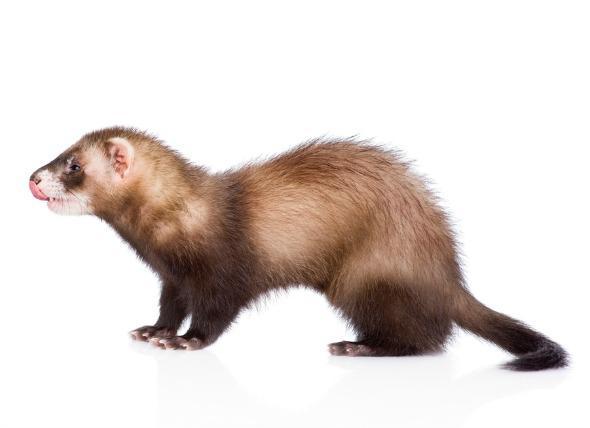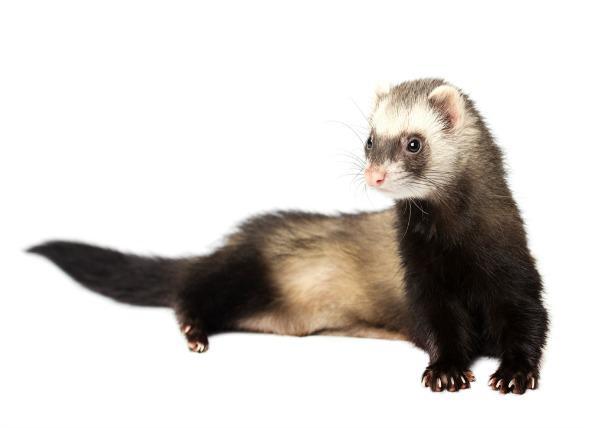The first image is the image on the left, the second image is the image on the right. For the images displayed, is the sentence "One image shows a ferret standing behind a bowl of food, with its tail extending to the left and its head turned leftward." factually correct? Answer yes or no. No. The first image is the image on the left, the second image is the image on the right. Assess this claim about the two images: "A ferret is eating out of a dish.". Correct or not? Answer yes or no. No. 